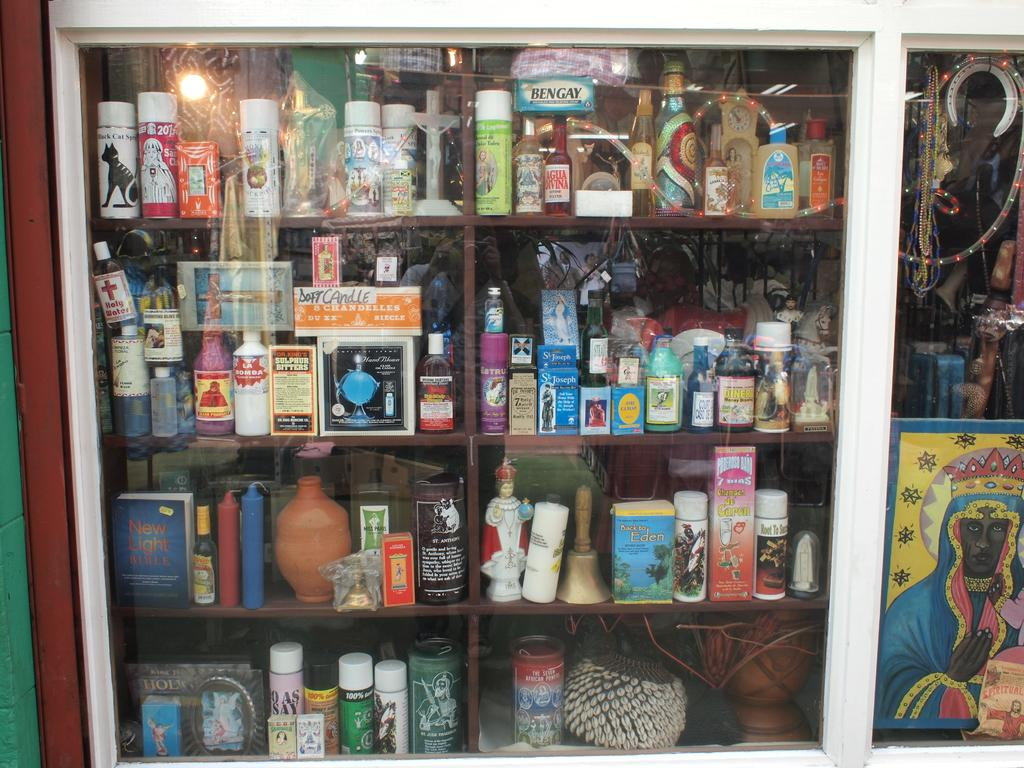<image>
Offer a succinct explanation of the picture presented. A glass case of various products including sulfur bitters. 